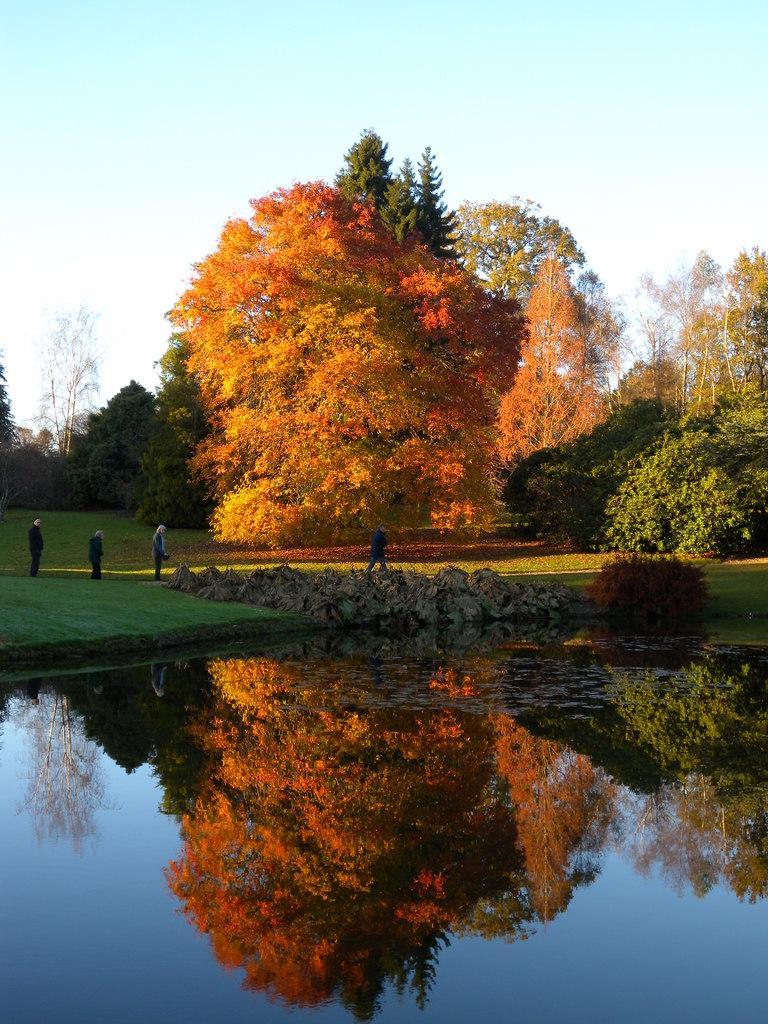Describe this image in one or two sentences. In this picture we can see people on the ground,here we can see water,trees and we can see sky in the background. 